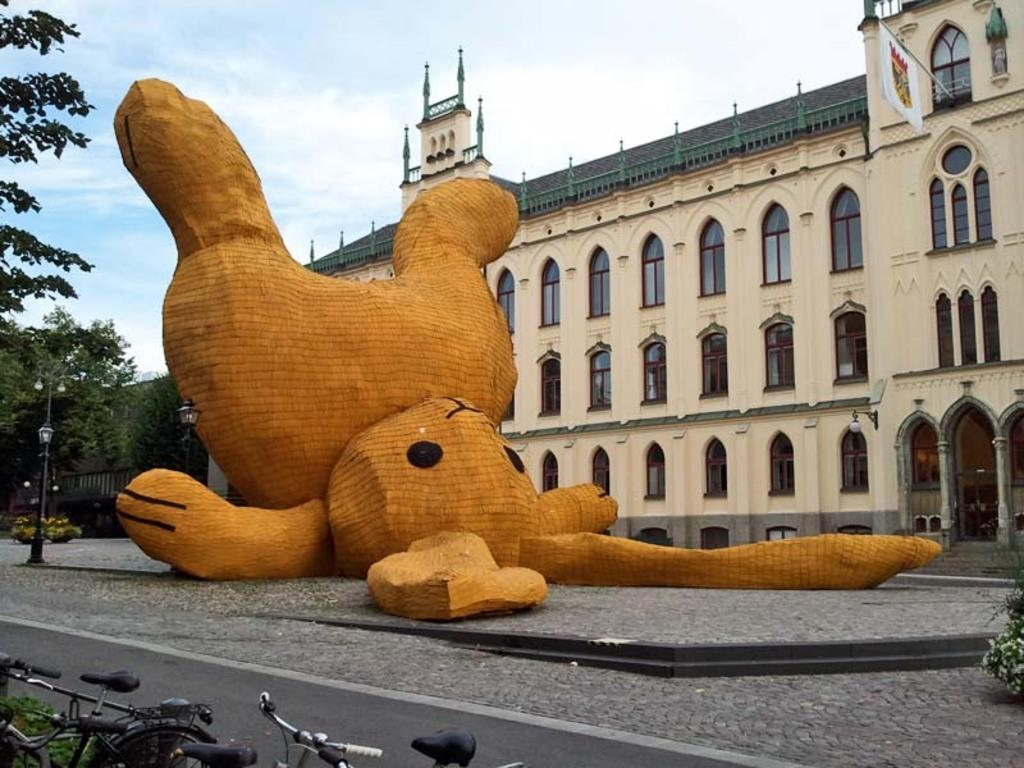What type of structure is visible in the image? There is a building in the image. What is located in front of the building? There is a sculpture in front of the building. What type of vegetation can be seen in the image? There are trees in the image. What mode of transportation is present in the image? There are bicycles in the image. What is visible at the top of the image? The sky is visible at the top of the image. What decorative element is present on the building? There is a flag on the building. How many nails are used to hold the bicycles together in the image? There are no nails visible in the image, as bicycles are typically held together by bolts and other fasteners. 